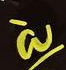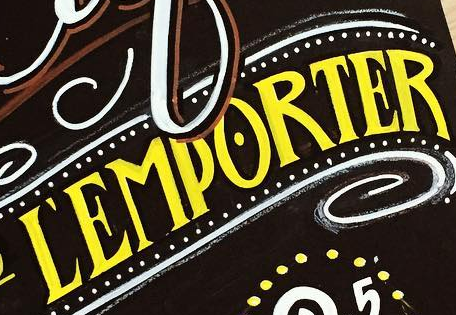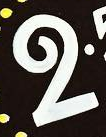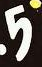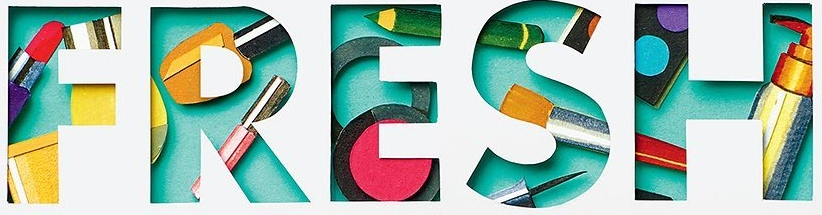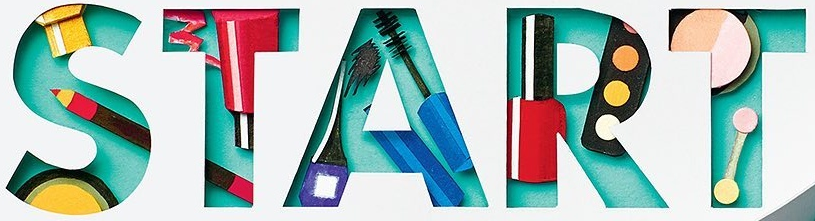Read the text content from these images in order, separated by a semicolon. à; ĽEMPORTER; 2; 5; FRESH; START 